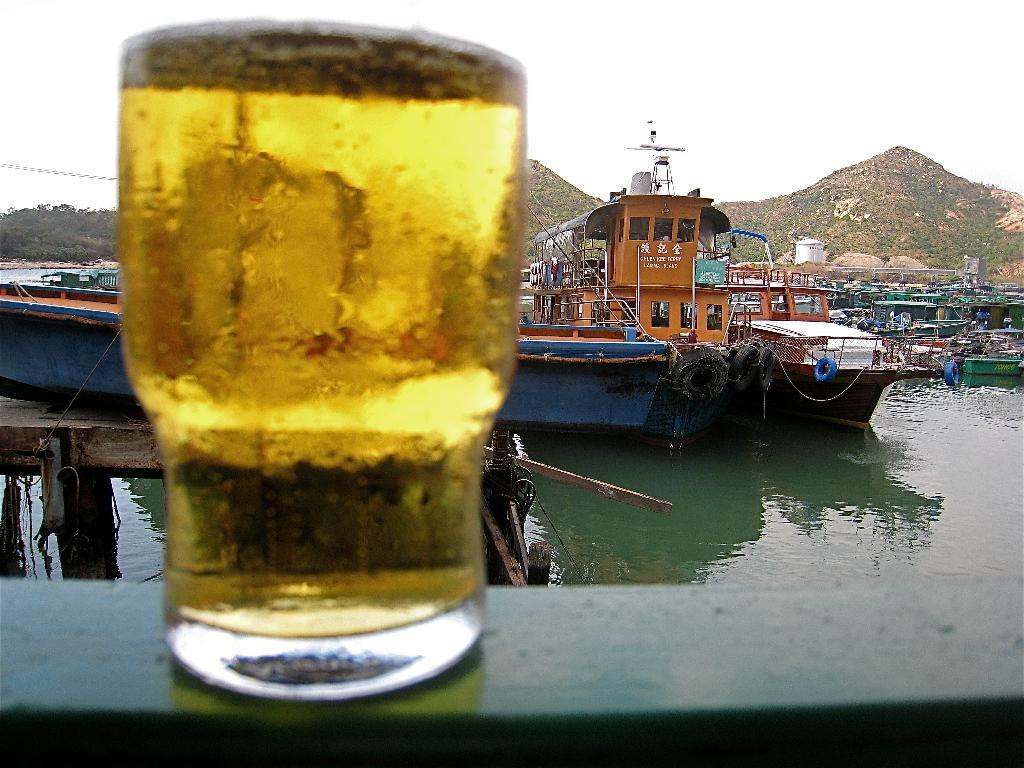What is in the glass that is visible in the image? There is a glass of wine in the image. What type of objects can be seen in the image besides the glass of wine? There are tubes, ships on the water, and trees visible in the image. What can be seen in the background of the image? The sky, mountains, and trees can be seen in the background of the image. What type of story is being told by the circle in the image? There is no circle present in the image, so no story can be associated with it. 